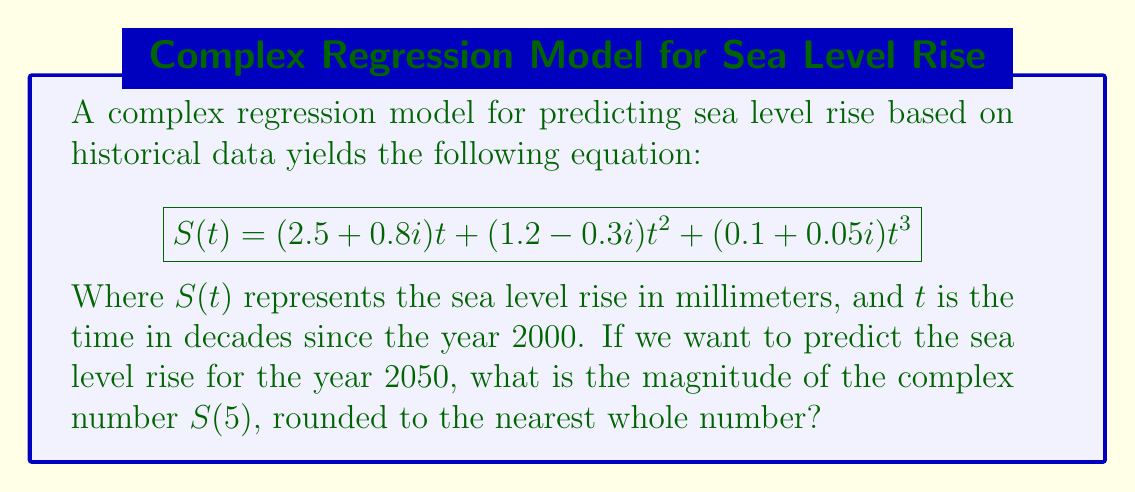Can you answer this question? To solve this problem, we'll follow these steps:

1) First, we need to calculate $S(5)$, as the year 2050 is 5 decades after 2000.

2) Let's substitute $t=5$ into the equation:

   $$S(5) = (2.5 + 0.8i)(5) + (1.2 - 0.3i)(5^2) + (0.1 + 0.05i)(5^3)$$

3) Simplify:
   
   $$S(5) = (12.5 + 4i) + (30 - 7.5i) + (12.5 + 6.25i)$$

4) Combine like terms:

   $$S(5) = 55 + 2.75i$$

5) To find the magnitude of this complex number, we use the formula $|a+bi| = \sqrt{a^2 + b^2}$:

   $$|S(5)| = \sqrt{55^2 + 2.75^2}$$

6) Calculate:

   $$|S(5)| = \sqrt{3025 + 7.5625} = \sqrt{3032.5625} \approx 55.07$$

7) Rounding to the nearest whole number:

   $$|S(5)| \approx 55$$
Answer: 55 mm 